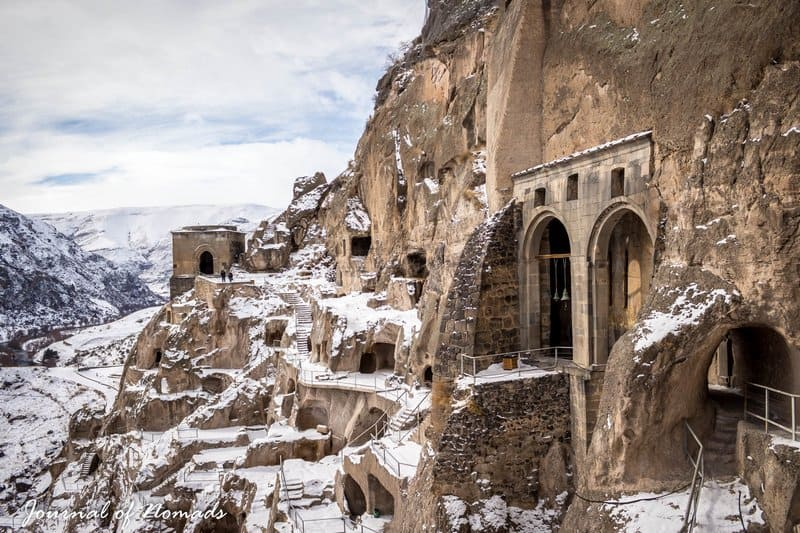What are the key architectural features visible in this image? The Vardzia cave monastery's architecture is characterized by its rock-hewn church with a beautifully preserved fresco of Queen Tamar, visible archways, and a series of terraces that follow the cliff’s natural line. The network of tunnels and access stairways carved into the cliff face demonstrate sophisticated engineering skills. The defensive and residential structures, including rooms carved into the rock, are aligned vertically, demonstrating efficient use of space and materials. 